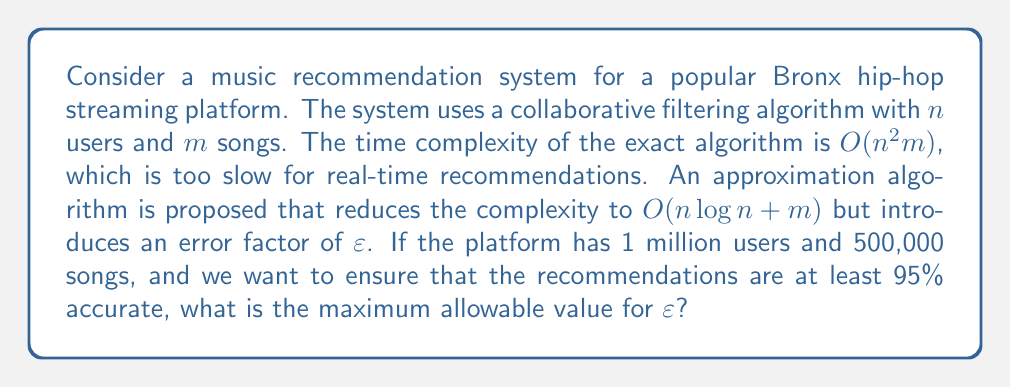Could you help me with this problem? To solve this problem, we need to understand the relationship between the error factor $\varepsilon$ and the accuracy of the recommendations. Let's break it down step by step:

1) The accuracy of the recommendations is given as 95%, which means the error rate is 5% or 0.05.

2) In approximation algorithms, the error factor $\varepsilon$ is typically related to the error rate as follows:

   $\text{Error Rate} = 1 - (1 - \varepsilon)$

3) We can set up the equation:

   $0.05 = 1 - (1 - \varepsilon)$

4) Simplifying:

   $0.95 = 1 - \varepsilon$

5) Solving for $\varepsilon$:

   $\varepsilon = 1 - 0.95 = 0.05$

Therefore, to ensure that the recommendations are at least 95% accurate, the maximum allowable value for $\varepsilon$ is 0.05 or 5%.

It's worth noting that this approximation algorithm significantly reduces the time complexity from $O(n^2m)$ to $O(n \log n + m)$. For the given numbers:

- Exact algorithm: $O((10^6)^2 \cdot 5 \cdot 10^5) = O(5 \cdot 10^{17})$
- Approximation algorithm: $O(10^6 \log 10^6 + 5 \cdot 10^5) \approx O(2 \cdot 10^7)$

This represents a substantial improvement in computational efficiency, making real-time recommendations feasible for large-scale music platforms like those popular in the Bronx hip-hop scene.
Answer: The maximum allowable value for $\varepsilon$ is 0.05 or 5%. 